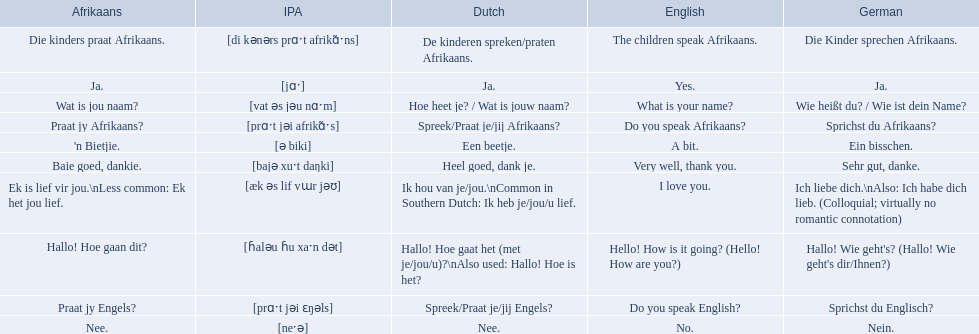Which phrases are said in africaans? Hallo! Hoe gaan dit?, Baie goed, dankie., Praat jy Afrikaans?, Praat jy Engels?, Ja., Nee., 'n Bietjie., Wat is jou naam?, Die kinders praat Afrikaans., Ek is lief vir jou.\nLess common: Ek het jou lief. Which of these mean how do you speak afrikaans? Praat jy Afrikaans?. 